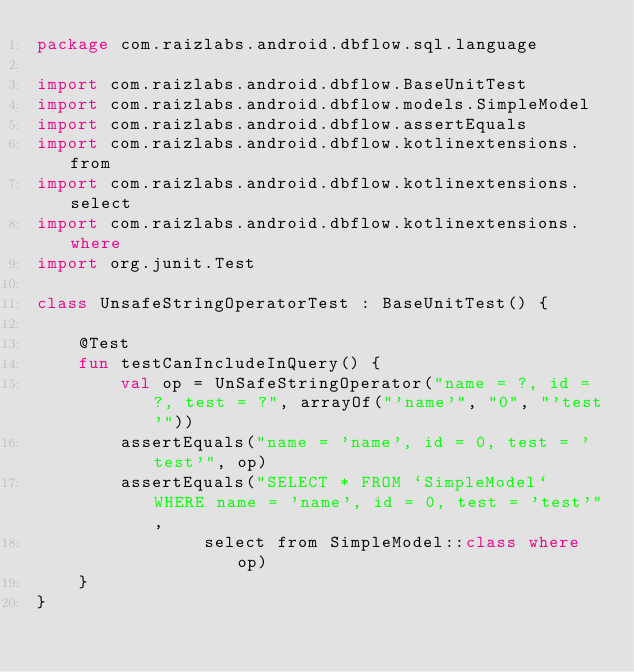Convert code to text. <code><loc_0><loc_0><loc_500><loc_500><_Kotlin_>package com.raizlabs.android.dbflow.sql.language

import com.raizlabs.android.dbflow.BaseUnitTest
import com.raizlabs.android.dbflow.models.SimpleModel
import com.raizlabs.android.dbflow.assertEquals
import com.raizlabs.android.dbflow.kotlinextensions.from
import com.raizlabs.android.dbflow.kotlinextensions.select
import com.raizlabs.android.dbflow.kotlinextensions.where
import org.junit.Test

class UnsafeStringOperatorTest : BaseUnitTest() {

    @Test
    fun testCanIncludeInQuery() {
        val op = UnSafeStringOperator("name = ?, id = ?, test = ?", arrayOf("'name'", "0", "'test'"))
        assertEquals("name = 'name', id = 0, test = 'test'", op)
        assertEquals("SELECT * FROM `SimpleModel` WHERE name = 'name', id = 0, test = 'test'",
                select from SimpleModel::class where op)
    }
}</code> 